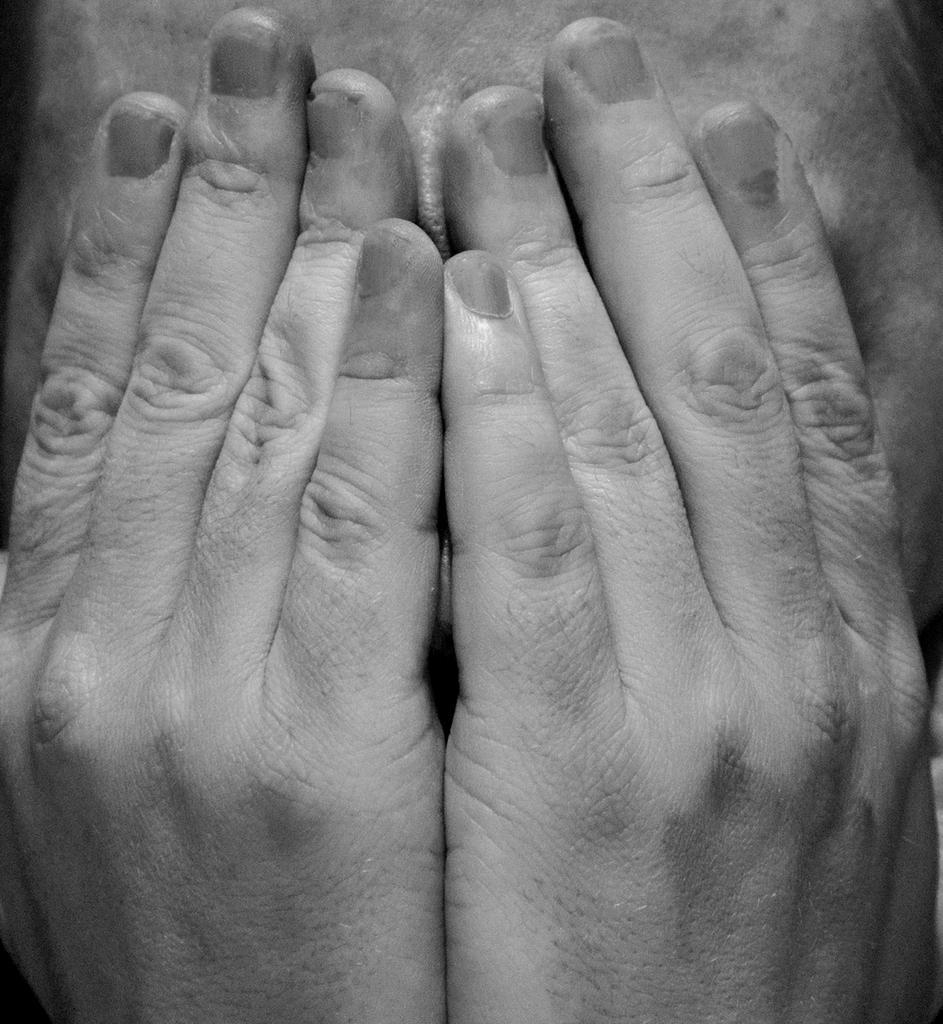Describe this image in one or two sentences. In this image I can see the person covering the face with hands. And this is a black and white image. 